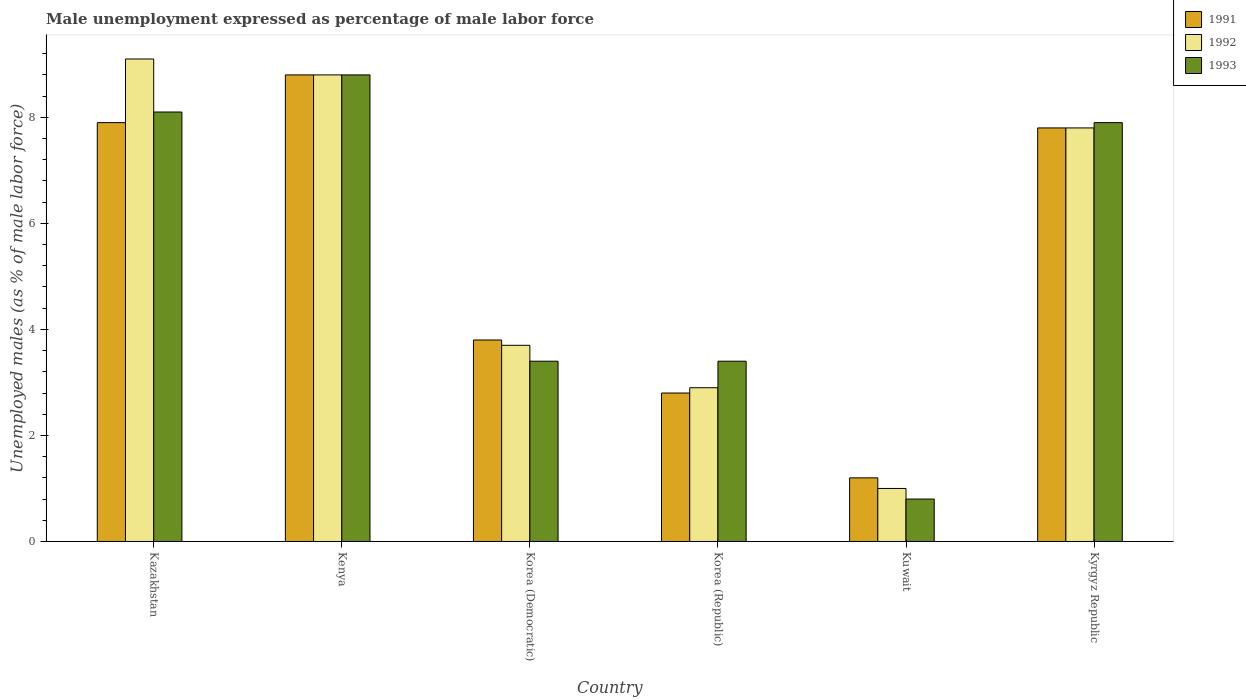How many groups of bars are there?
Provide a short and direct response. 6. How many bars are there on the 5th tick from the left?
Provide a short and direct response. 3. What is the label of the 5th group of bars from the left?
Your answer should be compact. Kuwait. In how many cases, is the number of bars for a given country not equal to the number of legend labels?
Your answer should be very brief. 0. What is the unemployment in males in in 1993 in Kazakhstan?
Make the answer very short. 8.1. Across all countries, what is the maximum unemployment in males in in 1993?
Offer a terse response. 8.8. Across all countries, what is the minimum unemployment in males in in 1993?
Provide a succinct answer. 0.8. In which country was the unemployment in males in in 1992 maximum?
Provide a short and direct response. Kazakhstan. In which country was the unemployment in males in in 1991 minimum?
Your response must be concise. Kuwait. What is the total unemployment in males in in 1992 in the graph?
Provide a short and direct response. 33.3. What is the difference between the unemployment in males in in 1993 in Kazakhstan and that in Korea (Democratic)?
Offer a terse response. 4.7. What is the difference between the unemployment in males in in 1992 in Kyrgyz Republic and the unemployment in males in in 1991 in Kuwait?
Offer a very short reply. 6.6. What is the average unemployment in males in in 1992 per country?
Keep it short and to the point. 5.55. What is the difference between the unemployment in males in of/in 1992 and unemployment in males in of/in 1993 in Korea (Democratic)?
Make the answer very short. 0.3. What is the ratio of the unemployment in males in in 1991 in Kenya to that in Kuwait?
Your response must be concise. 7.33. Is the difference between the unemployment in males in in 1992 in Korea (Republic) and Kuwait greater than the difference between the unemployment in males in in 1993 in Korea (Republic) and Kuwait?
Keep it short and to the point. No. What is the difference between the highest and the second highest unemployment in males in in 1992?
Provide a succinct answer. -0.3. What is the difference between the highest and the lowest unemployment in males in in 1991?
Keep it short and to the point. 7.6. In how many countries, is the unemployment in males in in 1993 greater than the average unemployment in males in in 1993 taken over all countries?
Ensure brevity in your answer.  3. What does the 3rd bar from the right in Kyrgyz Republic represents?
Your response must be concise. 1991. Is it the case that in every country, the sum of the unemployment in males in in 1991 and unemployment in males in in 1993 is greater than the unemployment in males in in 1992?
Offer a very short reply. Yes. Are all the bars in the graph horizontal?
Your answer should be compact. No. What is the difference between two consecutive major ticks on the Y-axis?
Keep it short and to the point. 2. Does the graph contain any zero values?
Your response must be concise. No. Does the graph contain grids?
Give a very brief answer. No. Where does the legend appear in the graph?
Ensure brevity in your answer.  Top right. How many legend labels are there?
Keep it short and to the point. 3. How are the legend labels stacked?
Provide a short and direct response. Vertical. What is the title of the graph?
Offer a terse response. Male unemployment expressed as percentage of male labor force. Does "1980" appear as one of the legend labels in the graph?
Keep it short and to the point. No. What is the label or title of the X-axis?
Your answer should be compact. Country. What is the label or title of the Y-axis?
Offer a terse response. Unemployed males (as % of male labor force). What is the Unemployed males (as % of male labor force) in 1991 in Kazakhstan?
Ensure brevity in your answer.  7.9. What is the Unemployed males (as % of male labor force) of 1992 in Kazakhstan?
Your response must be concise. 9.1. What is the Unemployed males (as % of male labor force) of 1993 in Kazakhstan?
Your answer should be very brief. 8.1. What is the Unemployed males (as % of male labor force) of 1991 in Kenya?
Offer a terse response. 8.8. What is the Unemployed males (as % of male labor force) of 1992 in Kenya?
Give a very brief answer. 8.8. What is the Unemployed males (as % of male labor force) of 1993 in Kenya?
Ensure brevity in your answer.  8.8. What is the Unemployed males (as % of male labor force) in 1991 in Korea (Democratic)?
Offer a very short reply. 3.8. What is the Unemployed males (as % of male labor force) of 1992 in Korea (Democratic)?
Offer a very short reply. 3.7. What is the Unemployed males (as % of male labor force) of 1993 in Korea (Democratic)?
Keep it short and to the point. 3.4. What is the Unemployed males (as % of male labor force) of 1991 in Korea (Republic)?
Provide a short and direct response. 2.8. What is the Unemployed males (as % of male labor force) of 1992 in Korea (Republic)?
Give a very brief answer. 2.9. What is the Unemployed males (as % of male labor force) of 1993 in Korea (Republic)?
Keep it short and to the point. 3.4. What is the Unemployed males (as % of male labor force) in 1991 in Kuwait?
Ensure brevity in your answer.  1.2. What is the Unemployed males (as % of male labor force) of 1993 in Kuwait?
Give a very brief answer. 0.8. What is the Unemployed males (as % of male labor force) of 1991 in Kyrgyz Republic?
Give a very brief answer. 7.8. What is the Unemployed males (as % of male labor force) in 1992 in Kyrgyz Republic?
Your response must be concise. 7.8. What is the Unemployed males (as % of male labor force) of 1993 in Kyrgyz Republic?
Your answer should be compact. 7.9. Across all countries, what is the maximum Unemployed males (as % of male labor force) in 1991?
Your response must be concise. 8.8. Across all countries, what is the maximum Unemployed males (as % of male labor force) of 1992?
Make the answer very short. 9.1. Across all countries, what is the maximum Unemployed males (as % of male labor force) of 1993?
Give a very brief answer. 8.8. Across all countries, what is the minimum Unemployed males (as % of male labor force) in 1991?
Keep it short and to the point. 1.2. Across all countries, what is the minimum Unemployed males (as % of male labor force) in 1992?
Your response must be concise. 1. Across all countries, what is the minimum Unemployed males (as % of male labor force) in 1993?
Make the answer very short. 0.8. What is the total Unemployed males (as % of male labor force) in 1991 in the graph?
Provide a short and direct response. 32.3. What is the total Unemployed males (as % of male labor force) of 1992 in the graph?
Offer a very short reply. 33.3. What is the total Unemployed males (as % of male labor force) of 1993 in the graph?
Ensure brevity in your answer.  32.4. What is the difference between the Unemployed males (as % of male labor force) of 1993 in Kazakhstan and that in Kenya?
Provide a succinct answer. -0.7. What is the difference between the Unemployed males (as % of male labor force) of 1992 in Kazakhstan and that in Korea (Democratic)?
Offer a very short reply. 5.4. What is the difference between the Unemployed males (as % of male labor force) in 1993 in Kazakhstan and that in Korea (Republic)?
Provide a short and direct response. 4.7. What is the difference between the Unemployed males (as % of male labor force) in 1991 in Kazakhstan and that in Kuwait?
Your response must be concise. 6.7. What is the difference between the Unemployed males (as % of male labor force) in 1993 in Kazakhstan and that in Kuwait?
Offer a terse response. 7.3. What is the difference between the Unemployed males (as % of male labor force) of 1991 in Kazakhstan and that in Kyrgyz Republic?
Give a very brief answer. 0.1. What is the difference between the Unemployed males (as % of male labor force) of 1992 in Kazakhstan and that in Kyrgyz Republic?
Provide a succinct answer. 1.3. What is the difference between the Unemployed males (as % of male labor force) in 1993 in Kenya and that in Korea (Republic)?
Provide a succinct answer. 5.4. What is the difference between the Unemployed males (as % of male labor force) in 1993 in Kenya and that in Kuwait?
Ensure brevity in your answer.  8. What is the difference between the Unemployed males (as % of male labor force) of 1993 in Kenya and that in Kyrgyz Republic?
Keep it short and to the point. 0.9. What is the difference between the Unemployed males (as % of male labor force) in 1991 in Korea (Democratic) and that in Korea (Republic)?
Provide a short and direct response. 1. What is the difference between the Unemployed males (as % of male labor force) in 1992 in Korea (Democratic) and that in Korea (Republic)?
Offer a terse response. 0.8. What is the difference between the Unemployed males (as % of male labor force) of 1993 in Korea (Democratic) and that in Korea (Republic)?
Give a very brief answer. 0. What is the difference between the Unemployed males (as % of male labor force) of 1991 in Korea (Democratic) and that in Kuwait?
Your answer should be very brief. 2.6. What is the difference between the Unemployed males (as % of male labor force) of 1992 in Korea (Democratic) and that in Kuwait?
Provide a succinct answer. 2.7. What is the difference between the Unemployed males (as % of male labor force) of 1993 in Korea (Democratic) and that in Kuwait?
Offer a very short reply. 2.6. What is the difference between the Unemployed males (as % of male labor force) in 1991 in Korea (Democratic) and that in Kyrgyz Republic?
Make the answer very short. -4. What is the difference between the Unemployed males (as % of male labor force) of 1993 in Korea (Democratic) and that in Kyrgyz Republic?
Your response must be concise. -4.5. What is the difference between the Unemployed males (as % of male labor force) in 1991 in Korea (Republic) and that in Kyrgyz Republic?
Give a very brief answer. -5. What is the difference between the Unemployed males (as % of male labor force) of 1992 in Korea (Republic) and that in Kyrgyz Republic?
Provide a succinct answer. -4.9. What is the difference between the Unemployed males (as % of male labor force) in 1991 in Kuwait and that in Kyrgyz Republic?
Keep it short and to the point. -6.6. What is the difference between the Unemployed males (as % of male labor force) in 1993 in Kuwait and that in Kyrgyz Republic?
Give a very brief answer. -7.1. What is the difference between the Unemployed males (as % of male labor force) in 1991 in Kazakhstan and the Unemployed males (as % of male labor force) in 1992 in Kenya?
Your response must be concise. -0.9. What is the difference between the Unemployed males (as % of male labor force) of 1991 in Kazakhstan and the Unemployed males (as % of male labor force) of 1993 in Kenya?
Ensure brevity in your answer.  -0.9. What is the difference between the Unemployed males (as % of male labor force) of 1991 in Kazakhstan and the Unemployed males (as % of male labor force) of 1992 in Korea (Democratic)?
Give a very brief answer. 4.2. What is the difference between the Unemployed males (as % of male labor force) of 1992 in Kazakhstan and the Unemployed males (as % of male labor force) of 1993 in Korea (Democratic)?
Give a very brief answer. 5.7. What is the difference between the Unemployed males (as % of male labor force) in 1991 in Kazakhstan and the Unemployed males (as % of male labor force) in 1992 in Kuwait?
Your response must be concise. 6.9. What is the difference between the Unemployed males (as % of male labor force) of 1991 in Kazakhstan and the Unemployed males (as % of male labor force) of 1993 in Kuwait?
Provide a succinct answer. 7.1. What is the difference between the Unemployed males (as % of male labor force) in 1991 in Kazakhstan and the Unemployed males (as % of male labor force) in 1992 in Kyrgyz Republic?
Give a very brief answer. 0.1. What is the difference between the Unemployed males (as % of male labor force) in 1991 in Kazakhstan and the Unemployed males (as % of male labor force) in 1993 in Kyrgyz Republic?
Keep it short and to the point. 0. What is the difference between the Unemployed males (as % of male labor force) in 1991 in Kenya and the Unemployed males (as % of male labor force) in 1993 in Korea (Democratic)?
Make the answer very short. 5.4. What is the difference between the Unemployed males (as % of male labor force) of 1991 in Kenya and the Unemployed males (as % of male labor force) of 1993 in Korea (Republic)?
Provide a short and direct response. 5.4. What is the difference between the Unemployed males (as % of male labor force) in 1992 in Kenya and the Unemployed males (as % of male labor force) in 1993 in Korea (Republic)?
Give a very brief answer. 5.4. What is the difference between the Unemployed males (as % of male labor force) in 1991 in Kenya and the Unemployed males (as % of male labor force) in 1993 in Kuwait?
Your answer should be compact. 8. What is the difference between the Unemployed males (as % of male labor force) of 1991 in Kenya and the Unemployed males (as % of male labor force) of 1992 in Kyrgyz Republic?
Keep it short and to the point. 1. What is the difference between the Unemployed males (as % of male labor force) of 1991 in Kenya and the Unemployed males (as % of male labor force) of 1993 in Kyrgyz Republic?
Your answer should be very brief. 0.9. What is the difference between the Unemployed males (as % of male labor force) of 1992 in Kenya and the Unemployed males (as % of male labor force) of 1993 in Kyrgyz Republic?
Ensure brevity in your answer.  0.9. What is the difference between the Unemployed males (as % of male labor force) of 1991 in Korea (Democratic) and the Unemployed males (as % of male labor force) of 1993 in Korea (Republic)?
Ensure brevity in your answer.  0.4. What is the difference between the Unemployed males (as % of male labor force) in 1991 in Korea (Democratic) and the Unemployed males (as % of male labor force) in 1992 in Kyrgyz Republic?
Provide a succinct answer. -4. What is the difference between the Unemployed males (as % of male labor force) in 1992 in Korea (Democratic) and the Unemployed males (as % of male labor force) in 1993 in Kyrgyz Republic?
Ensure brevity in your answer.  -4.2. What is the difference between the Unemployed males (as % of male labor force) of 1991 in Korea (Republic) and the Unemployed males (as % of male labor force) of 1993 in Kuwait?
Offer a terse response. 2. What is the difference between the Unemployed males (as % of male labor force) of 1991 in Korea (Republic) and the Unemployed males (as % of male labor force) of 1992 in Kyrgyz Republic?
Ensure brevity in your answer.  -5. What is the difference between the Unemployed males (as % of male labor force) in 1991 in Korea (Republic) and the Unemployed males (as % of male labor force) in 1993 in Kyrgyz Republic?
Give a very brief answer. -5.1. What is the difference between the Unemployed males (as % of male labor force) in 1992 in Korea (Republic) and the Unemployed males (as % of male labor force) in 1993 in Kyrgyz Republic?
Keep it short and to the point. -5. What is the difference between the Unemployed males (as % of male labor force) of 1992 in Kuwait and the Unemployed males (as % of male labor force) of 1993 in Kyrgyz Republic?
Make the answer very short. -6.9. What is the average Unemployed males (as % of male labor force) of 1991 per country?
Make the answer very short. 5.38. What is the average Unemployed males (as % of male labor force) of 1992 per country?
Ensure brevity in your answer.  5.55. What is the difference between the Unemployed males (as % of male labor force) of 1991 and Unemployed males (as % of male labor force) of 1992 in Kazakhstan?
Give a very brief answer. -1.2. What is the difference between the Unemployed males (as % of male labor force) of 1992 and Unemployed males (as % of male labor force) of 1993 in Kazakhstan?
Give a very brief answer. 1. What is the difference between the Unemployed males (as % of male labor force) in 1991 and Unemployed males (as % of male labor force) in 1992 in Kenya?
Offer a very short reply. 0. What is the difference between the Unemployed males (as % of male labor force) of 1992 and Unemployed males (as % of male labor force) of 1993 in Korea (Democratic)?
Your answer should be very brief. 0.3. What is the difference between the Unemployed males (as % of male labor force) in 1991 and Unemployed males (as % of male labor force) in 1993 in Korea (Republic)?
Give a very brief answer. -0.6. What is the difference between the Unemployed males (as % of male labor force) of 1991 and Unemployed males (as % of male labor force) of 1993 in Kyrgyz Republic?
Your answer should be very brief. -0.1. What is the difference between the Unemployed males (as % of male labor force) of 1992 and Unemployed males (as % of male labor force) of 1993 in Kyrgyz Republic?
Give a very brief answer. -0.1. What is the ratio of the Unemployed males (as % of male labor force) in 1991 in Kazakhstan to that in Kenya?
Provide a short and direct response. 0.9. What is the ratio of the Unemployed males (as % of male labor force) of 1992 in Kazakhstan to that in Kenya?
Your answer should be very brief. 1.03. What is the ratio of the Unemployed males (as % of male labor force) of 1993 in Kazakhstan to that in Kenya?
Ensure brevity in your answer.  0.92. What is the ratio of the Unemployed males (as % of male labor force) of 1991 in Kazakhstan to that in Korea (Democratic)?
Your answer should be very brief. 2.08. What is the ratio of the Unemployed males (as % of male labor force) in 1992 in Kazakhstan to that in Korea (Democratic)?
Provide a succinct answer. 2.46. What is the ratio of the Unemployed males (as % of male labor force) in 1993 in Kazakhstan to that in Korea (Democratic)?
Your answer should be compact. 2.38. What is the ratio of the Unemployed males (as % of male labor force) of 1991 in Kazakhstan to that in Korea (Republic)?
Your answer should be compact. 2.82. What is the ratio of the Unemployed males (as % of male labor force) of 1992 in Kazakhstan to that in Korea (Republic)?
Your response must be concise. 3.14. What is the ratio of the Unemployed males (as % of male labor force) in 1993 in Kazakhstan to that in Korea (Republic)?
Give a very brief answer. 2.38. What is the ratio of the Unemployed males (as % of male labor force) in 1991 in Kazakhstan to that in Kuwait?
Provide a short and direct response. 6.58. What is the ratio of the Unemployed males (as % of male labor force) of 1993 in Kazakhstan to that in Kuwait?
Make the answer very short. 10.12. What is the ratio of the Unemployed males (as % of male labor force) of 1991 in Kazakhstan to that in Kyrgyz Republic?
Keep it short and to the point. 1.01. What is the ratio of the Unemployed males (as % of male labor force) in 1993 in Kazakhstan to that in Kyrgyz Republic?
Give a very brief answer. 1.03. What is the ratio of the Unemployed males (as % of male labor force) in 1991 in Kenya to that in Korea (Democratic)?
Your response must be concise. 2.32. What is the ratio of the Unemployed males (as % of male labor force) of 1992 in Kenya to that in Korea (Democratic)?
Your response must be concise. 2.38. What is the ratio of the Unemployed males (as % of male labor force) of 1993 in Kenya to that in Korea (Democratic)?
Keep it short and to the point. 2.59. What is the ratio of the Unemployed males (as % of male labor force) of 1991 in Kenya to that in Korea (Republic)?
Your answer should be compact. 3.14. What is the ratio of the Unemployed males (as % of male labor force) of 1992 in Kenya to that in Korea (Republic)?
Provide a short and direct response. 3.03. What is the ratio of the Unemployed males (as % of male labor force) of 1993 in Kenya to that in Korea (Republic)?
Give a very brief answer. 2.59. What is the ratio of the Unemployed males (as % of male labor force) of 1991 in Kenya to that in Kuwait?
Offer a terse response. 7.33. What is the ratio of the Unemployed males (as % of male labor force) of 1991 in Kenya to that in Kyrgyz Republic?
Keep it short and to the point. 1.13. What is the ratio of the Unemployed males (as % of male labor force) in 1992 in Kenya to that in Kyrgyz Republic?
Your answer should be very brief. 1.13. What is the ratio of the Unemployed males (as % of male labor force) in 1993 in Kenya to that in Kyrgyz Republic?
Provide a short and direct response. 1.11. What is the ratio of the Unemployed males (as % of male labor force) in 1991 in Korea (Democratic) to that in Korea (Republic)?
Your answer should be compact. 1.36. What is the ratio of the Unemployed males (as % of male labor force) in 1992 in Korea (Democratic) to that in Korea (Republic)?
Ensure brevity in your answer.  1.28. What is the ratio of the Unemployed males (as % of male labor force) in 1991 in Korea (Democratic) to that in Kuwait?
Make the answer very short. 3.17. What is the ratio of the Unemployed males (as % of male labor force) of 1993 in Korea (Democratic) to that in Kuwait?
Make the answer very short. 4.25. What is the ratio of the Unemployed males (as % of male labor force) of 1991 in Korea (Democratic) to that in Kyrgyz Republic?
Ensure brevity in your answer.  0.49. What is the ratio of the Unemployed males (as % of male labor force) of 1992 in Korea (Democratic) to that in Kyrgyz Republic?
Offer a terse response. 0.47. What is the ratio of the Unemployed males (as % of male labor force) of 1993 in Korea (Democratic) to that in Kyrgyz Republic?
Your answer should be compact. 0.43. What is the ratio of the Unemployed males (as % of male labor force) of 1991 in Korea (Republic) to that in Kuwait?
Your answer should be compact. 2.33. What is the ratio of the Unemployed males (as % of male labor force) in 1993 in Korea (Republic) to that in Kuwait?
Offer a very short reply. 4.25. What is the ratio of the Unemployed males (as % of male labor force) of 1991 in Korea (Republic) to that in Kyrgyz Republic?
Offer a terse response. 0.36. What is the ratio of the Unemployed males (as % of male labor force) of 1992 in Korea (Republic) to that in Kyrgyz Republic?
Provide a short and direct response. 0.37. What is the ratio of the Unemployed males (as % of male labor force) of 1993 in Korea (Republic) to that in Kyrgyz Republic?
Give a very brief answer. 0.43. What is the ratio of the Unemployed males (as % of male labor force) of 1991 in Kuwait to that in Kyrgyz Republic?
Keep it short and to the point. 0.15. What is the ratio of the Unemployed males (as % of male labor force) in 1992 in Kuwait to that in Kyrgyz Republic?
Keep it short and to the point. 0.13. What is the ratio of the Unemployed males (as % of male labor force) of 1993 in Kuwait to that in Kyrgyz Republic?
Your response must be concise. 0.1. What is the difference between the highest and the second highest Unemployed males (as % of male labor force) in 1993?
Offer a terse response. 0.7. What is the difference between the highest and the lowest Unemployed males (as % of male labor force) of 1993?
Keep it short and to the point. 8. 